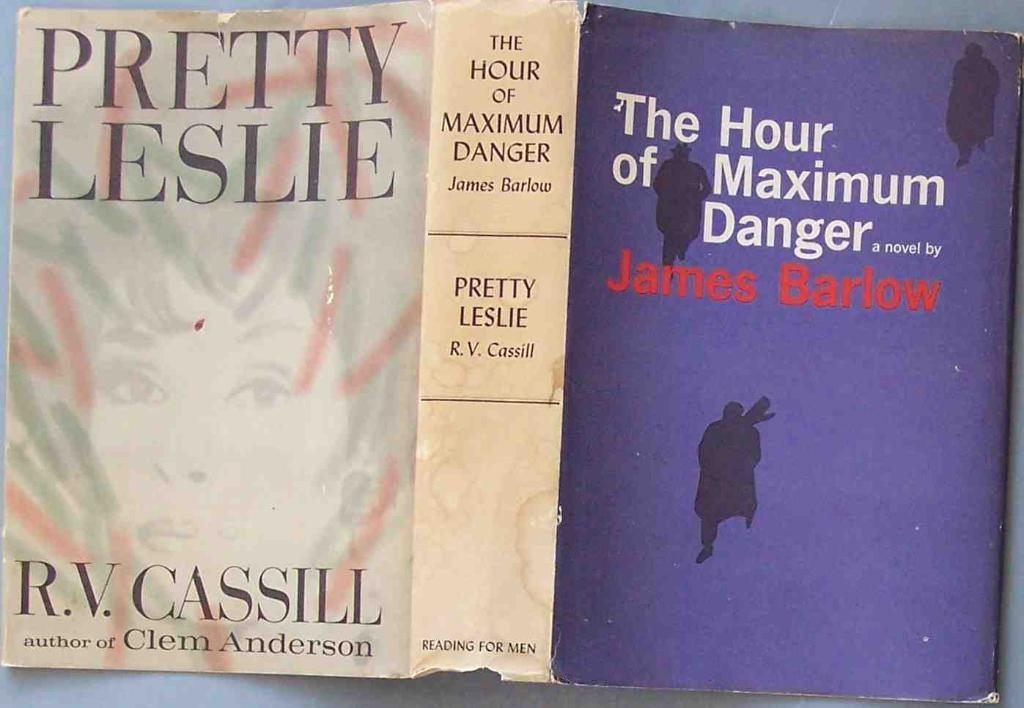<image>
Present a compact description of the photo's key features. A book cover that is titled "The hour of maximum danger". 